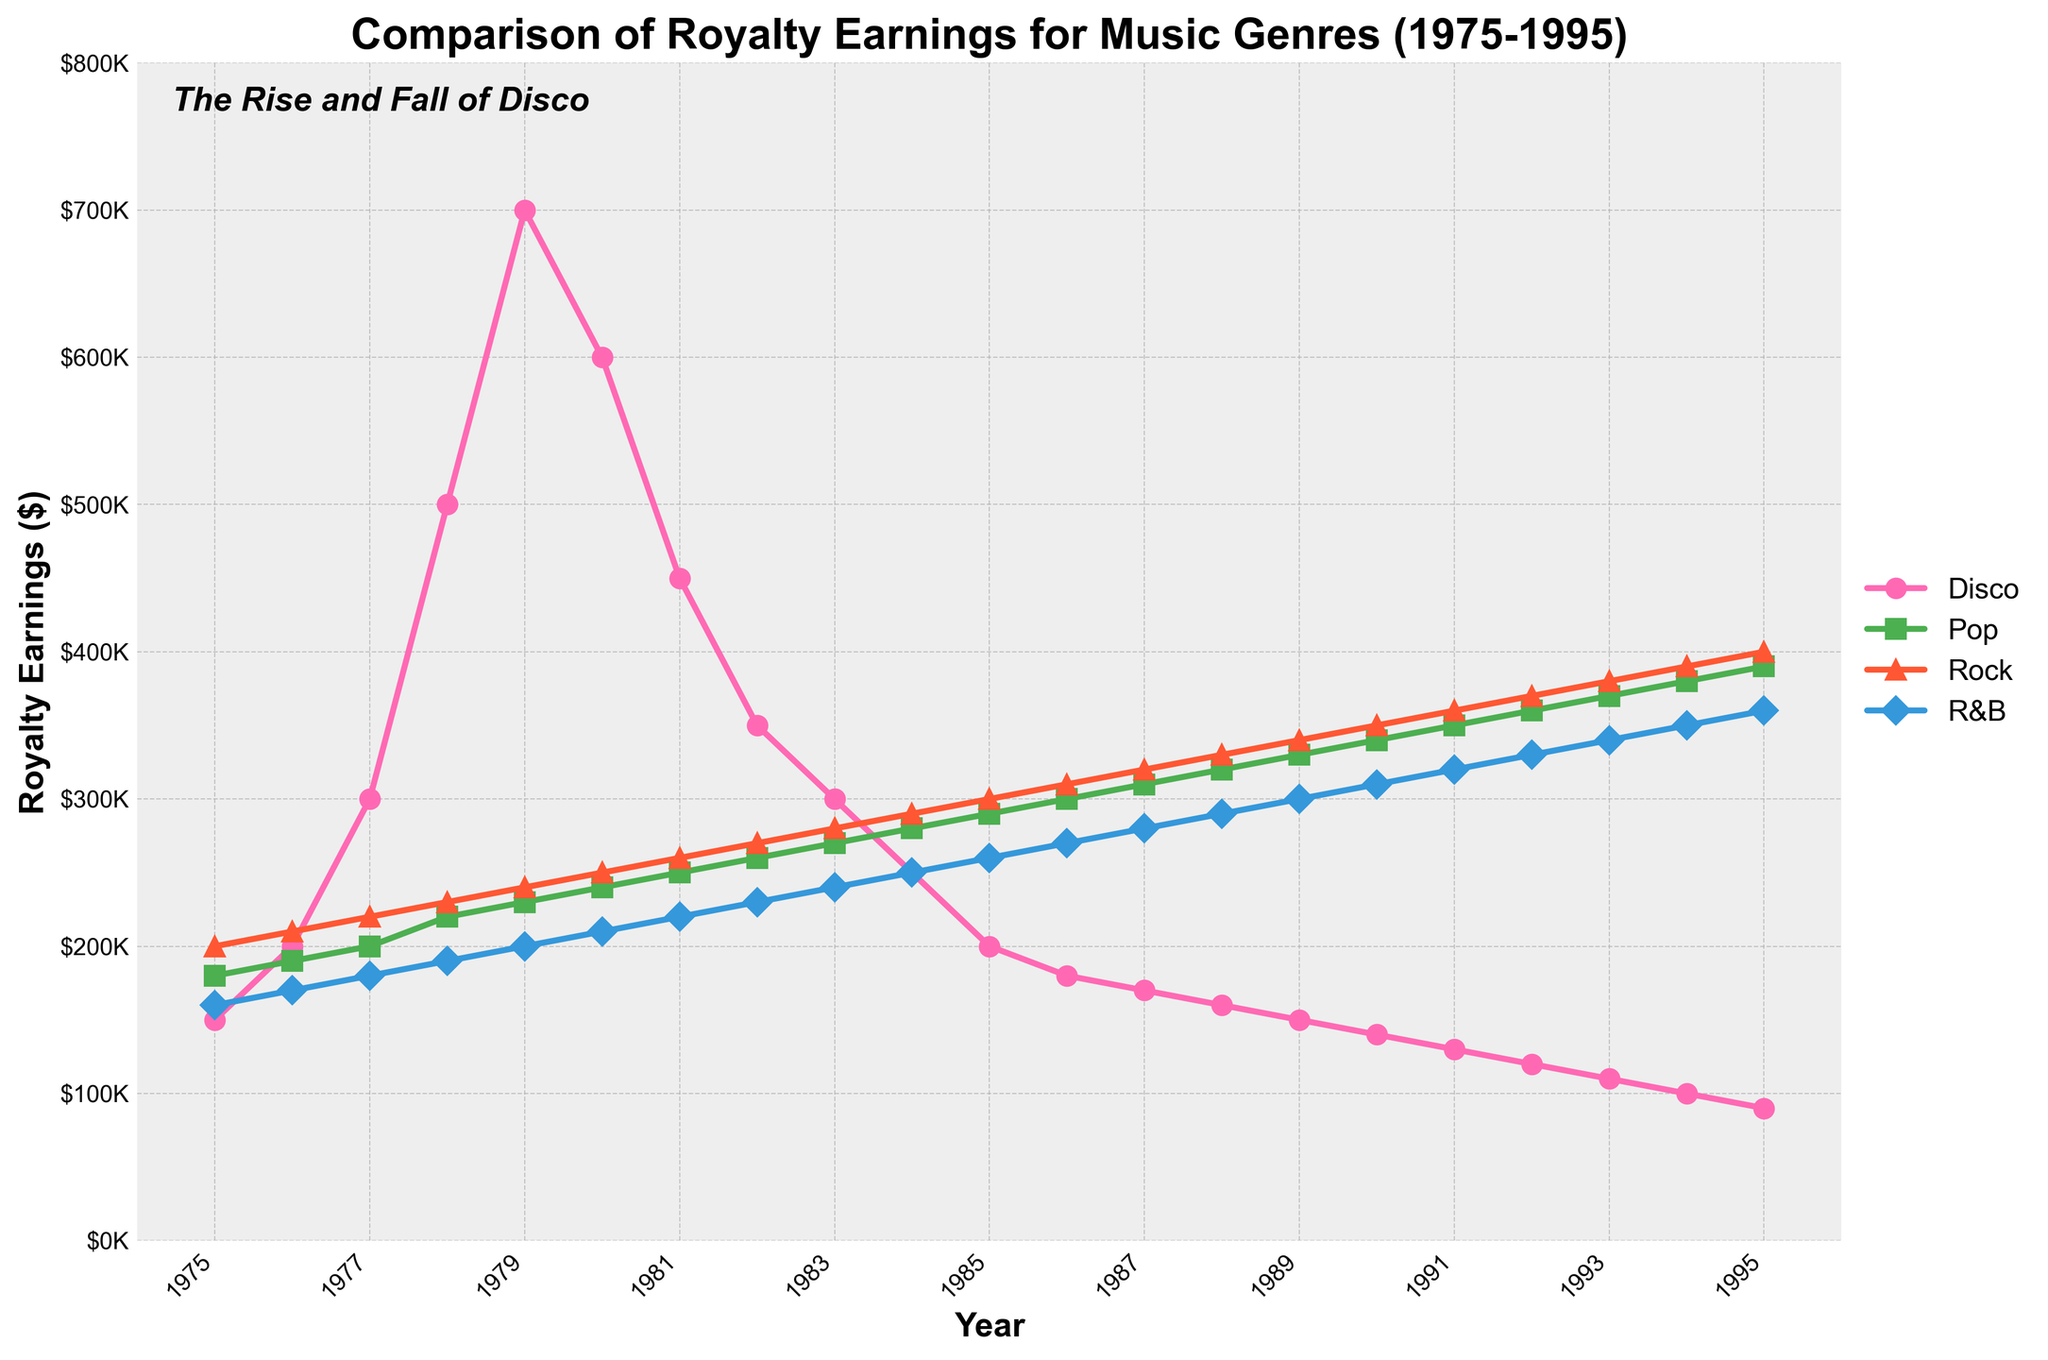What is the peak royalty earnings for Disco, and in which year did it occur? The peak for Disco can be identified by looking for the highest point in the Disco line on the plot. The highest point is at $700,000, which occurs in 1979.
Answer: $700,000 in 1979 How do the royalty earnings for Disco in 1985 compare to those for Rock in the same year? Comparing the values at 1985 for both Disco and Rock from the plot, we see that Disco earned $200,000, while Rock earned $300,000.
Answer: $200,000 for Disco and $300,000 for Rock What year did Disco earnings fall below $200,000, and how many years did they stay above that value? The graph shows that Disco earnings fell below $200,000 in 1985. From 1975 to 1984, Disco earnings were consistently above $200,000. Thus, they stayed above that value for 10 years.
Answer: 1985 and 10 years In which year did Pop surpass Disco in royalty earnings, and was this change sustained in the following years? The plot shows Pop surpassing Disco in 1983 when Disco earnings were around $300,000 and Pop's earnings were around $270,000. From 1983 onwards, Pop consistently earned more than Disco every year.
Answer: 1983 and sustained What is the trend of Disco royalty earnings from their peak in 1979 until the end of the data period in 1995? Examining the line for Disco from its peak in 1979 ($700,000) until 1995, the trend shows a steady decline, dropping to $90,000 by 1995.
Answer: Steady decline By how much did Rock earnings grow from 1975 to 1995? Rock earnings in 1975 were $200,000, and in 1995 they were $400,000. The increase is obtained by subtracting the earlier value from the later value: $400,000 - $200,000 = $200,000.
Answer: $200,000 What visual difference stands out in the trend lines of Disco compared to other genres? Visually, the Disco line shows a sharp rise followed by a steep decline, whereas other genres show a more gradual and steady increase throughout the years.
Answer: Sharp rise and steep decline for Disco; gradual rise for others How does the ending royalty earnings in 1995 for R&B compare to those of Rock? Looking at the ending points in 1995 for both R&B and Rock, R&B is at $360,000 while Rock is at $400,000.
Answer: $360,000 for R&B, $400,000 for Rock 